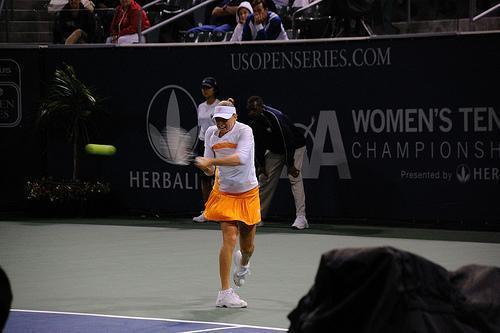How many people are standing behind the tennis player?
Give a very brief answer. 2. How many people are seen on the court?
Give a very brief answer. 3. How many people holding the racket?
Give a very brief answer. 1. How many tennis players are pictured?
Give a very brief answer. 1. 